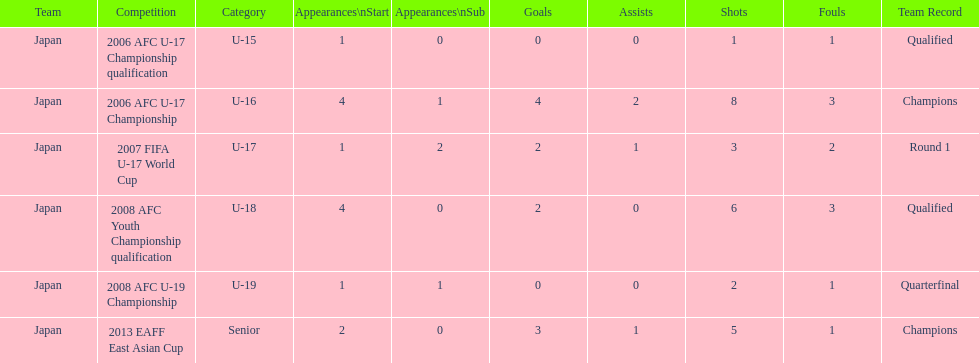What was yoichiro kakitani's first major competition? 2006 AFC U-17 Championship qualification. 